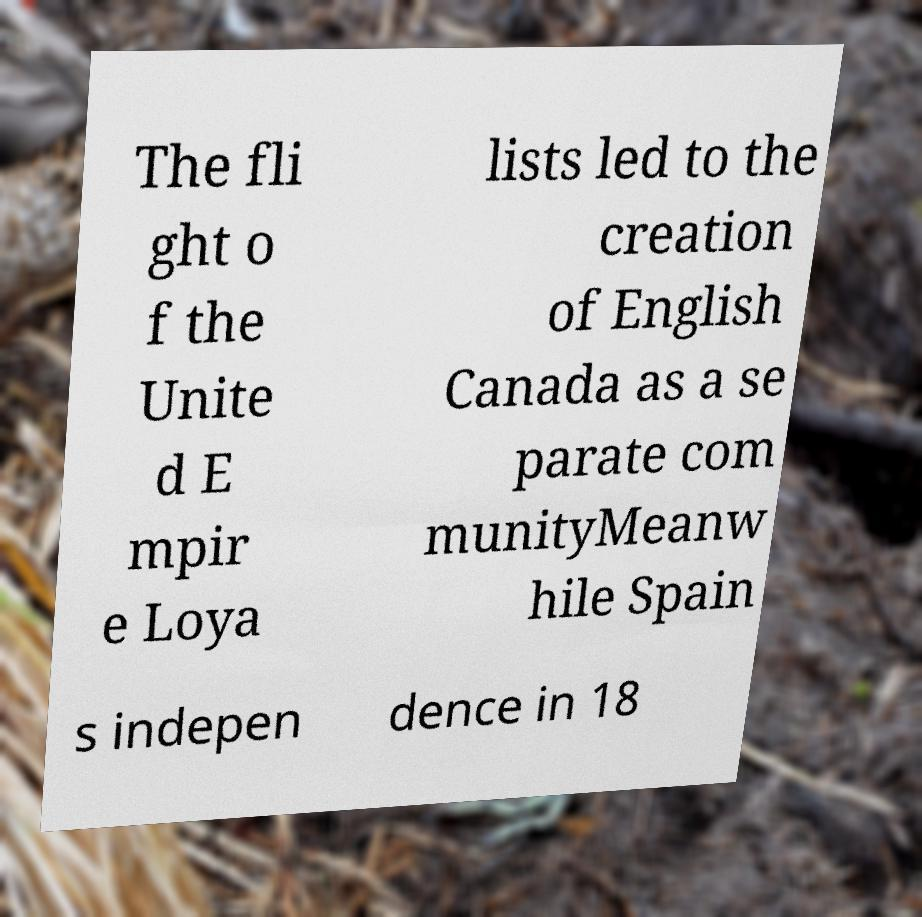For documentation purposes, I need the text within this image transcribed. Could you provide that? The fli ght o f the Unite d E mpir e Loya lists led to the creation of English Canada as a se parate com munityMeanw hile Spain s indepen dence in 18 